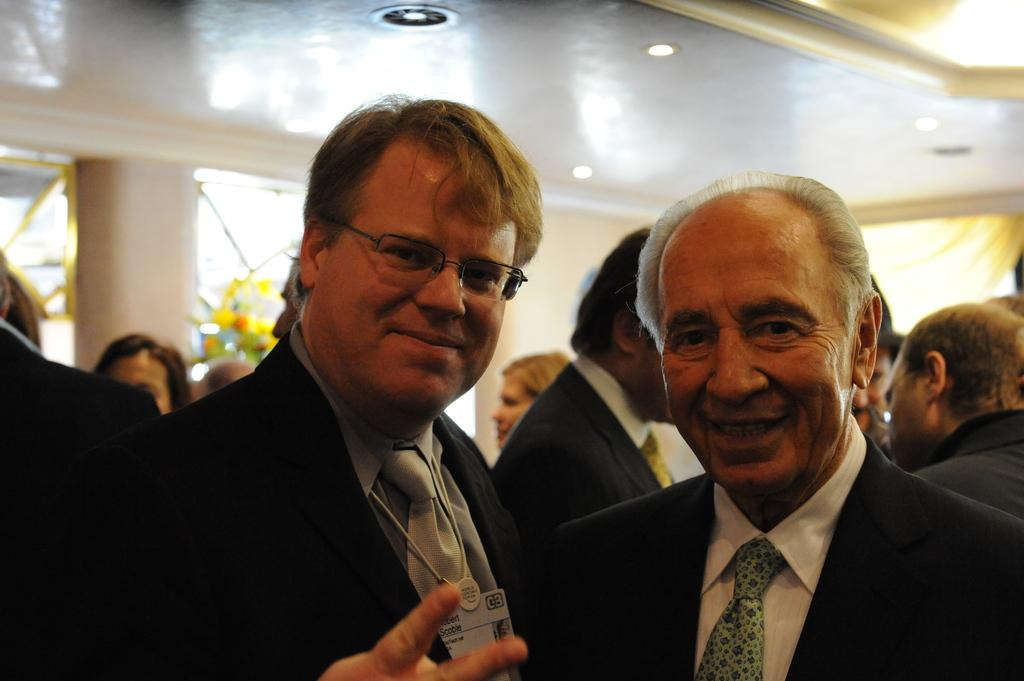How many people are in the front of the image? There are two persons in the front side of the image. What is the arrangement of people in the image? Many people are present behind the two persons in the front. Can you describe any architectural features in the image? Yes, there is a pillar on the left backside of the image. What type of apples can be seen growing on the drum in the image? There is no drum or apples present in the image. 